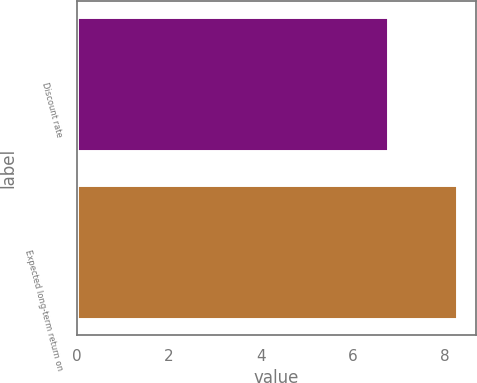<chart> <loc_0><loc_0><loc_500><loc_500><bar_chart><fcel>Discount rate<fcel>Expected long-term return on<nl><fcel>6.75<fcel>8.25<nl></chart> 